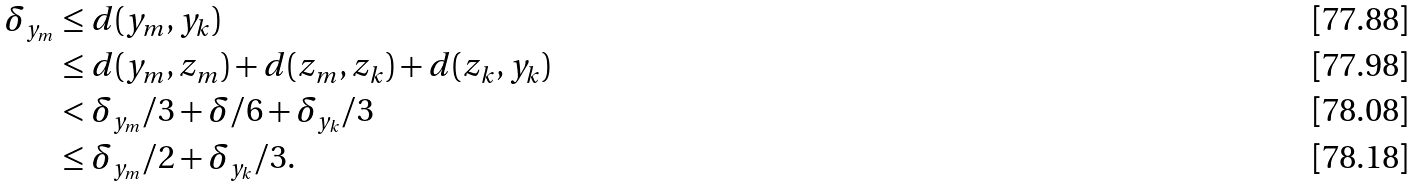Convert formula to latex. <formula><loc_0><loc_0><loc_500><loc_500>\delta _ { y _ { m } } & \leq d ( y _ { m } , y _ { k } ) \\ & \leq d ( y _ { m } , z _ { m } ) + d ( z _ { m } , z _ { k } ) + d ( z _ { k } , y _ { k } ) \\ & < \delta _ { y _ { m } } / 3 + \delta / 6 + \delta _ { y _ { k } } / 3 \\ & \leq \delta _ { y _ { m } } / 2 + \delta _ { y _ { k } } / 3 .</formula> 